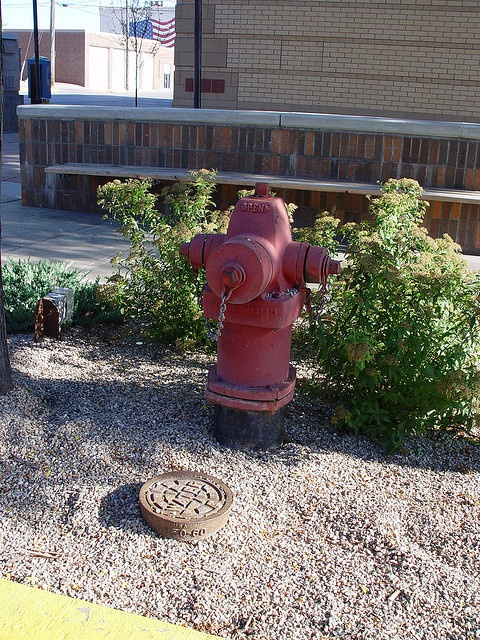Describe the objects in this image and their specific colors. I can see a fire hydrant in purple, maroon, and black tones in this image. 